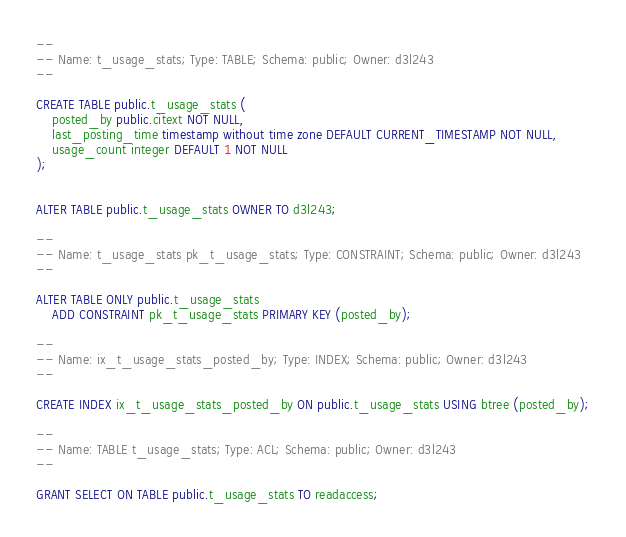Convert code to text. <code><loc_0><loc_0><loc_500><loc_500><_SQL_>--
-- Name: t_usage_stats; Type: TABLE; Schema: public; Owner: d3l243
--

CREATE TABLE public.t_usage_stats (
    posted_by public.citext NOT NULL,
    last_posting_time timestamp without time zone DEFAULT CURRENT_TIMESTAMP NOT NULL,
    usage_count integer DEFAULT 1 NOT NULL
);


ALTER TABLE public.t_usage_stats OWNER TO d3l243;

--
-- Name: t_usage_stats pk_t_usage_stats; Type: CONSTRAINT; Schema: public; Owner: d3l243
--

ALTER TABLE ONLY public.t_usage_stats
    ADD CONSTRAINT pk_t_usage_stats PRIMARY KEY (posted_by);

--
-- Name: ix_t_usage_stats_posted_by; Type: INDEX; Schema: public; Owner: d3l243
--

CREATE INDEX ix_t_usage_stats_posted_by ON public.t_usage_stats USING btree (posted_by);

--
-- Name: TABLE t_usage_stats; Type: ACL; Schema: public; Owner: d3l243
--

GRANT SELECT ON TABLE public.t_usage_stats TO readaccess;

</code> 